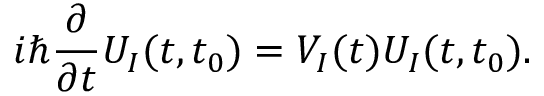<formula> <loc_0><loc_0><loc_500><loc_500>i \hbar { } \partial } { \partial t } U _ { I } ( t , t _ { 0 } ) = V _ { I } ( t ) U _ { I } ( t , t _ { 0 } ) .</formula> 